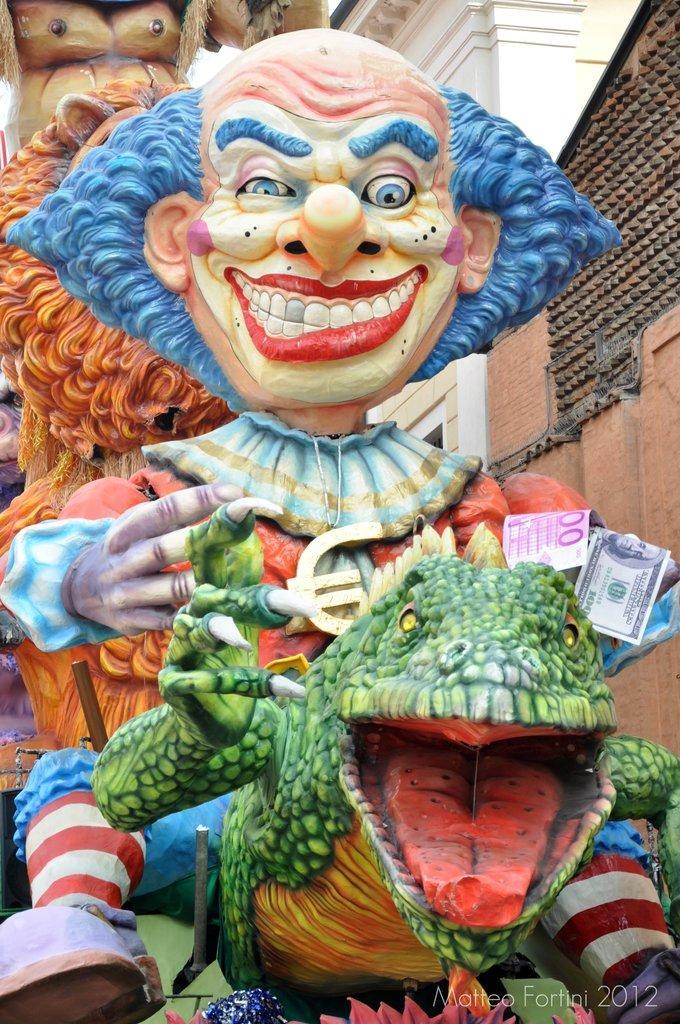Could you give a brief overview of what you see in this image? In the image we can see statues of monsters. Beside them there are some buildings. 